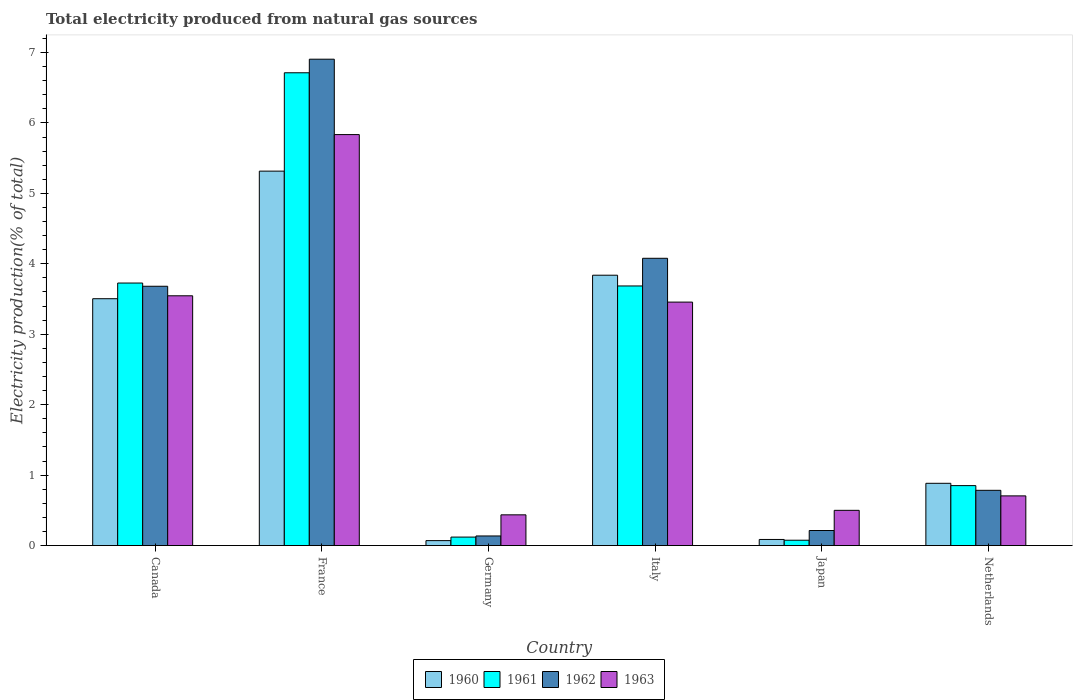How many different coloured bars are there?
Offer a terse response. 4. How many bars are there on the 5th tick from the right?
Your answer should be compact. 4. In how many cases, is the number of bars for a given country not equal to the number of legend labels?
Your answer should be very brief. 0. What is the total electricity produced in 1960 in Italy?
Offer a terse response. 3.84. Across all countries, what is the maximum total electricity produced in 1961?
Provide a succinct answer. 6.71. Across all countries, what is the minimum total electricity produced in 1962?
Your answer should be very brief. 0.14. In which country was the total electricity produced in 1961 minimum?
Make the answer very short. Japan. What is the total total electricity produced in 1960 in the graph?
Keep it short and to the point. 13.7. What is the difference between the total electricity produced in 1960 in France and that in Japan?
Keep it short and to the point. 5.23. What is the difference between the total electricity produced in 1960 in Germany and the total electricity produced in 1961 in Japan?
Your response must be concise. -0.01. What is the average total electricity produced in 1963 per country?
Provide a succinct answer. 2.41. What is the difference between the total electricity produced of/in 1963 and total electricity produced of/in 1960 in Germany?
Your answer should be compact. 0.37. What is the ratio of the total electricity produced in 1960 in Canada to that in Japan?
Your answer should be very brief. 40.48. Is the total electricity produced in 1961 in Germany less than that in Japan?
Offer a very short reply. No. Is the difference between the total electricity produced in 1963 in Italy and Netherlands greater than the difference between the total electricity produced in 1960 in Italy and Netherlands?
Keep it short and to the point. No. What is the difference between the highest and the second highest total electricity produced in 1963?
Offer a terse response. -0.09. What is the difference between the highest and the lowest total electricity produced in 1961?
Provide a succinct answer. 6.64. In how many countries, is the total electricity produced in 1962 greater than the average total electricity produced in 1962 taken over all countries?
Ensure brevity in your answer.  3. Is the sum of the total electricity produced in 1960 in France and Italy greater than the maximum total electricity produced in 1963 across all countries?
Provide a succinct answer. Yes. How many countries are there in the graph?
Provide a short and direct response. 6. What is the difference between two consecutive major ticks on the Y-axis?
Keep it short and to the point. 1. Does the graph contain any zero values?
Offer a very short reply. No. Does the graph contain grids?
Your answer should be very brief. No. Where does the legend appear in the graph?
Provide a short and direct response. Bottom center. How many legend labels are there?
Ensure brevity in your answer.  4. What is the title of the graph?
Provide a succinct answer. Total electricity produced from natural gas sources. Does "2014" appear as one of the legend labels in the graph?
Offer a very short reply. No. What is the label or title of the Y-axis?
Keep it short and to the point. Electricity production(% of total). What is the Electricity production(% of total) in 1960 in Canada?
Make the answer very short. 3.5. What is the Electricity production(% of total) in 1961 in Canada?
Ensure brevity in your answer.  3.73. What is the Electricity production(% of total) in 1962 in Canada?
Your answer should be very brief. 3.68. What is the Electricity production(% of total) in 1963 in Canada?
Provide a succinct answer. 3.55. What is the Electricity production(% of total) in 1960 in France?
Your response must be concise. 5.32. What is the Electricity production(% of total) in 1961 in France?
Keep it short and to the point. 6.71. What is the Electricity production(% of total) of 1962 in France?
Keep it short and to the point. 6.91. What is the Electricity production(% of total) of 1963 in France?
Offer a very short reply. 5.83. What is the Electricity production(% of total) of 1960 in Germany?
Offer a terse response. 0.07. What is the Electricity production(% of total) of 1961 in Germany?
Offer a terse response. 0.12. What is the Electricity production(% of total) of 1962 in Germany?
Make the answer very short. 0.14. What is the Electricity production(% of total) in 1963 in Germany?
Your answer should be very brief. 0.44. What is the Electricity production(% of total) in 1960 in Italy?
Provide a succinct answer. 3.84. What is the Electricity production(% of total) of 1961 in Italy?
Your answer should be compact. 3.69. What is the Electricity production(% of total) in 1962 in Italy?
Give a very brief answer. 4.08. What is the Electricity production(% of total) in 1963 in Italy?
Provide a succinct answer. 3.46. What is the Electricity production(% of total) of 1960 in Japan?
Give a very brief answer. 0.09. What is the Electricity production(% of total) in 1961 in Japan?
Your answer should be very brief. 0.08. What is the Electricity production(% of total) of 1962 in Japan?
Keep it short and to the point. 0.21. What is the Electricity production(% of total) in 1963 in Japan?
Give a very brief answer. 0.5. What is the Electricity production(% of total) of 1960 in Netherlands?
Keep it short and to the point. 0.88. What is the Electricity production(% of total) in 1961 in Netherlands?
Your answer should be very brief. 0.85. What is the Electricity production(% of total) in 1962 in Netherlands?
Your answer should be very brief. 0.78. What is the Electricity production(% of total) of 1963 in Netherlands?
Your response must be concise. 0.71. Across all countries, what is the maximum Electricity production(% of total) in 1960?
Your answer should be compact. 5.32. Across all countries, what is the maximum Electricity production(% of total) in 1961?
Ensure brevity in your answer.  6.71. Across all countries, what is the maximum Electricity production(% of total) in 1962?
Make the answer very short. 6.91. Across all countries, what is the maximum Electricity production(% of total) of 1963?
Provide a succinct answer. 5.83. Across all countries, what is the minimum Electricity production(% of total) of 1960?
Make the answer very short. 0.07. Across all countries, what is the minimum Electricity production(% of total) of 1961?
Your answer should be compact. 0.08. Across all countries, what is the minimum Electricity production(% of total) in 1962?
Give a very brief answer. 0.14. Across all countries, what is the minimum Electricity production(% of total) of 1963?
Offer a very short reply. 0.44. What is the total Electricity production(% of total) of 1960 in the graph?
Your answer should be very brief. 13.7. What is the total Electricity production(% of total) of 1961 in the graph?
Ensure brevity in your answer.  15.17. What is the total Electricity production(% of total) of 1962 in the graph?
Give a very brief answer. 15.8. What is the total Electricity production(% of total) in 1963 in the graph?
Provide a short and direct response. 14.48. What is the difference between the Electricity production(% of total) of 1960 in Canada and that in France?
Ensure brevity in your answer.  -1.81. What is the difference between the Electricity production(% of total) in 1961 in Canada and that in France?
Provide a succinct answer. -2.99. What is the difference between the Electricity production(% of total) in 1962 in Canada and that in France?
Your answer should be very brief. -3.22. What is the difference between the Electricity production(% of total) of 1963 in Canada and that in France?
Keep it short and to the point. -2.29. What is the difference between the Electricity production(% of total) of 1960 in Canada and that in Germany?
Your answer should be very brief. 3.43. What is the difference between the Electricity production(% of total) in 1961 in Canada and that in Germany?
Your answer should be compact. 3.61. What is the difference between the Electricity production(% of total) of 1962 in Canada and that in Germany?
Your response must be concise. 3.55. What is the difference between the Electricity production(% of total) in 1963 in Canada and that in Germany?
Your response must be concise. 3.11. What is the difference between the Electricity production(% of total) of 1960 in Canada and that in Italy?
Provide a short and direct response. -0.33. What is the difference between the Electricity production(% of total) in 1961 in Canada and that in Italy?
Keep it short and to the point. 0.04. What is the difference between the Electricity production(% of total) of 1962 in Canada and that in Italy?
Provide a short and direct response. -0.4. What is the difference between the Electricity production(% of total) of 1963 in Canada and that in Italy?
Provide a short and direct response. 0.09. What is the difference between the Electricity production(% of total) of 1960 in Canada and that in Japan?
Provide a succinct answer. 3.42. What is the difference between the Electricity production(% of total) of 1961 in Canada and that in Japan?
Offer a terse response. 3.65. What is the difference between the Electricity production(% of total) in 1962 in Canada and that in Japan?
Ensure brevity in your answer.  3.47. What is the difference between the Electricity production(% of total) in 1963 in Canada and that in Japan?
Offer a terse response. 3.05. What is the difference between the Electricity production(% of total) in 1960 in Canada and that in Netherlands?
Provide a short and direct response. 2.62. What is the difference between the Electricity production(% of total) of 1961 in Canada and that in Netherlands?
Offer a very short reply. 2.88. What is the difference between the Electricity production(% of total) in 1962 in Canada and that in Netherlands?
Your answer should be compact. 2.9. What is the difference between the Electricity production(% of total) in 1963 in Canada and that in Netherlands?
Your answer should be compact. 2.84. What is the difference between the Electricity production(% of total) in 1960 in France and that in Germany?
Offer a terse response. 5.25. What is the difference between the Electricity production(% of total) of 1961 in France and that in Germany?
Ensure brevity in your answer.  6.59. What is the difference between the Electricity production(% of total) in 1962 in France and that in Germany?
Provide a succinct answer. 6.77. What is the difference between the Electricity production(% of total) in 1963 in France and that in Germany?
Offer a very short reply. 5.4. What is the difference between the Electricity production(% of total) in 1960 in France and that in Italy?
Ensure brevity in your answer.  1.48. What is the difference between the Electricity production(% of total) in 1961 in France and that in Italy?
Offer a very short reply. 3.03. What is the difference between the Electricity production(% of total) of 1962 in France and that in Italy?
Keep it short and to the point. 2.83. What is the difference between the Electricity production(% of total) of 1963 in France and that in Italy?
Provide a succinct answer. 2.38. What is the difference between the Electricity production(% of total) in 1960 in France and that in Japan?
Make the answer very short. 5.23. What is the difference between the Electricity production(% of total) of 1961 in France and that in Japan?
Provide a short and direct response. 6.64. What is the difference between the Electricity production(% of total) of 1962 in France and that in Japan?
Ensure brevity in your answer.  6.69. What is the difference between the Electricity production(% of total) of 1963 in France and that in Japan?
Give a very brief answer. 5.33. What is the difference between the Electricity production(% of total) of 1960 in France and that in Netherlands?
Offer a terse response. 4.43. What is the difference between the Electricity production(% of total) of 1961 in France and that in Netherlands?
Ensure brevity in your answer.  5.86. What is the difference between the Electricity production(% of total) in 1962 in France and that in Netherlands?
Offer a very short reply. 6.12. What is the difference between the Electricity production(% of total) in 1963 in France and that in Netherlands?
Your answer should be compact. 5.13. What is the difference between the Electricity production(% of total) of 1960 in Germany and that in Italy?
Your response must be concise. -3.77. What is the difference between the Electricity production(% of total) of 1961 in Germany and that in Italy?
Give a very brief answer. -3.57. What is the difference between the Electricity production(% of total) in 1962 in Germany and that in Italy?
Offer a terse response. -3.94. What is the difference between the Electricity production(% of total) in 1963 in Germany and that in Italy?
Offer a very short reply. -3.02. What is the difference between the Electricity production(% of total) in 1960 in Germany and that in Japan?
Provide a succinct answer. -0.02. What is the difference between the Electricity production(% of total) of 1961 in Germany and that in Japan?
Make the answer very short. 0.04. What is the difference between the Electricity production(% of total) of 1962 in Germany and that in Japan?
Give a very brief answer. -0.08. What is the difference between the Electricity production(% of total) of 1963 in Germany and that in Japan?
Offer a terse response. -0.06. What is the difference between the Electricity production(% of total) in 1960 in Germany and that in Netherlands?
Your response must be concise. -0.81. What is the difference between the Electricity production(% of total) in 1961 in Germany and that in Netherlands?
Keep it short and to the point. -0.73. What is the difference between the Electricity production(% of total) in 1962 in Germany and that in Netherlands?
Ensure brevity in your answer.  -0.65. What is the difference between the Electricity production(% of total) of 1963 in Germany and that in Netherlands?
Provide a succinct answer. -0.27. What is the difference between the Electricity production(% of total) in 1960 in Italy and that in Japan?
Ensure brevity in your answer.  3.75. What is the difference between the Electricity production(% of total) of 1961 in Italy and that in Japan?
Your answer should be compact. 3.61. What is the difference between the Electricity production(% of total) of 1962 in Italy and that in Japan?
Provide a short and direct response. 3.86. What is the difference between the Electricity production(% of total) in 1963 in Italy and that in Japan?
Your response must be concise. 2.96. What is the difference between the Electricity production(% of total) in 1960 in Italy and that in Netherlands?
Keep it short and to the point. 2.95. What is the difference between the Electricity production(% of total) of 1961 in Italy and that in Netherlands?
Your answer should be very brief. 2.83. What is the difference between the Electricity production(% of total) in 1962 in Italy and that in Netherlands?
Your answer should be compact. 3.29. What is the difference between the Electricity production(% of total) of 1963 in Italy and that in Netherlands?
Offer a terse response. 2.75. What is the difference between the Electricity production(% of total) of 1960 in Japan and that in Netherlands?
Your answer should be very brief. -0.8. What is the difference between the Electricity production(% of total) in 1961 in Japan and that in Netherlands?
Offer a terse response. -0.78. What is the difference between the Electricity production(% of total) in 1962 in Japan and that in Netherlands?
Your answer should be very brief. -0.57. What is the difference between the Electricity production(% of total) in 1963 in Japan and that in Netherlands?
Give a very brief answer. -0.21. What is the difference between the Electricity production(% of total) of 1960 in Canada and the Electricity production(% of total) of 1961 in France?
Your answer should be compact. -3.21. What is the difference between the Electricity production(% of total) in 1960 in Canada and the Electricity production(% of total) in 1962 in France?
Make the answer very short. -3.4. What is the difference between the Electricity production(% of total) of 1960 in Canada and the Electricity production(% of total) of 1963 in France?
Your answer should be compact. -2.33. What is the difference between the Electricity production(% of total) of 1961 in Canada and the Electricity production(% of total) of 1962 in France?
Keep it short and to the point. -3.18. What is the difference between the Electricity production(% of total) in 1961 in Canada and the Electricity production(% of total) in 1963 in France?
Your answer should be compact. -2.11. What is the difference between the Electricity production(% of total) of 1962 in Canada and the Electricity production(% of total) of 1963 in France?
Your answer should be very brief. -2.15. What is the difference between the Electricity production(% of total) of 1960 in Canada and the Electricity production(% of total) of 1961 in Germany?
Make the answer very short. 3.38. What is the difference between the Electricity production(% of total) in 1960 in Canada and the Electricity production(% of total) in 1962 in Germany?
Your answer should be compact. 3.37. What is the difference between the Electricity production(% of total) in 1960 in Canada and the Electricity production(% of total) in 1963 in Germany?
Make the answer very short. 3.07. What is the difference between the Electricity production(% of total) of 1961 in Canada and the Electricity production(% of total) of 1962 in Germany?
Ensure brevity in your answer.  3.59. What is the difference between the Electricity production(% of total) in 1961 in Canada and the Electricity production(% of total) in 1963 in Germany?
Your response must be concise. 3.29. What is the difference between the Electricity production(% of total) in 1962 in Canada and the Electricity production(% of total) in 1963 in Germany?
Your answer should be very brief. 3.25. What is the difference between the Electricity production(% of total) in 1960 in Canada and the Electricity production(% of total) in 1961 in Italy?
Your answer should be compact. -0.18. What is the difference between the Electricity production(% of total) in 1960 in Canada and the Electricity production(% of total) in 1962 in Italy?
Your answer should be very brief. -0.57. What is the difference between the Electricity production(% of total) of 1960 in Canada and the Electricity production(% of total) of 1963 in Italy?
Provide a short and direct response. 0.05. What is the difference between the Electricity production(% of total) of 1961 in Canada and the Electricity production(% of total) of 1962 in Italy?
Your response must be concise. -0.35. What is the difference between the Electricity production(% of total) in 1961 in Canada and the Electricity production(% of total) in 1963 in Italy?
Your answer should be very brief. 0.27. What is the difference between the Electricity production(% of total) of 1962 in Canada and the Electricity production(% of total) of 1963 in Italy?
Give a very brief answer. 0.23. What is the difference between the Electricity production(% of total) of 1960 in Canada and the Electricity production(% of total) of 1961 in Japan?
Your response must be concise. 3.43. What is the difference between the Electricity production(% of total) of 1960 in Canada and the Electricity production(% of total) of 1962 in Japan?
Keep it short and to the point. 3.29. What is the difference between the Electricity production(% of total) in 1960 in Canada and the Electricity production(% of total) in 1963 in Japan?
Your response must be concise. 3. What is the difference between the Electricity production(% of total) of 1961 in Canada and the Electricity production(% of total) of 1962 in Japan?
Your answer should be very brief. 3.51. What is the difference between the Electricity production(% of total) in 1961 in Canada and the Electricity production(% of total) in 1963 in Japan?
Provide a short and direct response. 3.23. What is the difference between the Electricity production(% of total) of 1962 in Canada and the Electricity production(% of total) of 1963 in Japan?
Give a very brief answer. 3.18. What is the difference between the Electricity production(% of total) of 1960 in Canada and the Electricity production(% of total) of 1961 in Netherlands?
Keep it short and to the point. 2.65. What is the difference between the Electricity production(% of total) of 1960 in Canada and the Electricity production(% of total) of 1962 in Netherlands?
Give a very brief answer. 2.72. What is the difference between the Electricity production(% of total) of 1960 in Canada and the Electricity production(% of total) of 1963 in Netherlands?
Offer a terse response. 2.8. What is the difference between the Electricity production(% of total) in 1961 in Canada and the Electricity production(% of total) in 1962 in Netherlands?
Your response must be concise. 2.94. What is the difference between the Electricity production(% of total) in 1961 in Canada and the Electricity production(% of total) in 1963 in Netherlands?
Offer a terse response. 3.02. What is the difference between the Electricity production(% of total) in 1962 in Canada and the Electricity production(% of total) in 1963 in Netherlands?
Make the answer very short. 2.98. What is the difference between the Electricity production(% of total) of 1960 in France and the Electricity production(% of total) of 1961 in Germany?
Your response must be concise. 5.2. What is the difference between the Electricity production(% of total) of 1960 in France and the Electricity production(% of total) of 1962 in Germany?
Your answer should be very brief. 5.18. What is the difference between the Electricity production(% of total) of 1960 in France and the Electricity production(% of total) of 1963 in Germany?
Make the answer very short. 4.88. What is the difference between the Electricity production(% of total) in 1961 in France and the Electricity production(% of total) in 1962 in Germany?
Make the answer very short. 6.58. What is the difference between the Electricity production(% of total) in 1961 in France and the Electricity production(% of total) in 1963 in Germany?
Provide a succinct answer. 6.28. What is the difference between the Electricity production(% of total) in 1962 in France and the Electricity production(% of total) in 1963 in Germany?
Offer a very short reply. 6.47. What is the difference between the Electricity production(% of total) in 1960 in France and the Electricity production(% of total) in 1961 in Italy?
Give a very brief answer. 1.63. What is the difference between the Electricity production(% of total) in 1960 in France and the Electricity production(% of total) in 1962 in Italy?
Give a very brief answer. 1.24. What is the difference between the Electricity production(% of total) in 1960 in France and the Electricity production(% of total) in 1963 in Italy?
Give a very brief answer. 1.86. What is the difference between the Electricity production(% of total) of 1961 in France and the Electricity production(% of total) of 1962 in Italy?
Ensure brevity in your answer.  2.63. What is the difference between the Electricity production(% of total) of 1961 in France and the Electricity production(% of total) of 1963 in Italy?
Give a very brief answer. 3.26. What is the difference between the Electricity production(% of total) of 1962 in France and the Electricity production(% of total) of 1963 in Italy?
Keep it short and to the point. 3.45. What is the difference between the Electricity production(% of total) in 1960 in France and the Electricity production(% of total) in 1961 in Japan?
Offer a terse response. 5.24. What is the difference between the Electricity production(% of total) in 1960 in France and the Electricity production(% of total) in 1962 in Japan?
Keep it short and to the point. 5.1. What is the difference between the Electricity production(% of total) of 1960 in France and the Electricity production(% of total) of 1963 in Japan?
Offer a very short reply. 4.82. What is the difference between the Electricity production(% of total) in 1961 in France and the Electricity production(% of total) in 1962 in Japan?
Make the answer very short. 6.5. What is the difference between the Electricity production(% of total) of 1961 in France and the Electricity production(% of total) of 1963 in Japan?
Your answer should be compact. 6.21. What is the difference between the Electricity production(% of total) in 1962 in France and the Electricity production(% of total) in 1963 in Japan?
Ensure brevity in your answer.  6.4. What is the difference between the Electricity production(% of total) in 1960 in France and the Electricity production(% of total) in 1961 in Netherlands?
Offer a very short reply. 4.46. What is the difference between the Electricity production(% of total) of 1960 in France and the Electricity production(% of total) of 1962 in Netherlands?
Your response must be concise. 4.53. What is the difference between the Electricity production(% of total) in 1960 in France and the Electricity production(% of total) in 1963 in Netherlands?
Your response must be concise. 4.61. What is the difference between the Electricity production(% of total) of 1961 in France and the Electricity production(% of total) of 1962 in Netherlands?
Your answer should be compact. 5.93. What is the difference between the Electricity production(% of total) in 1961 in France and the Electricity production(% of total) in 1963 in Netherlands?
Ensure brevity in your answer.  6.01. What is the difference between the Electricity production(% of total) of 1962 in France and the Electricity production(% of total) of 1963 in Netherlands?
Your response must be concise. 6.2. What is the difference between the Electricity production(% of total) in 1960 in Germany and the Electricity production(% of total) in 1961 in Italy?
Offer a terse response. -3.62. What is the difference between the Electricity production(% of total) in 1960 in Germany and the Electricity production(% of total) in 1962 in Italy?
Your answer should be compact. -4.01. What is the difference between the Electricity production(% of total) in 1960 in Germany and the Electricity production(% of total) in 1963 in Italy?
Provide a short and direct response. -3.39. What is the difference between the Electricity production(% of total) of 1961 in Germany and the Electricity production(% of total) of 1962 in Italy?
Give a very brief answer. -3.96. What is the difference between the Electricity production(% of total) in 1961 in Germany and the Electricity production(% of total) in 1963 in Italy?
Keep it short and to the point. -3.34. What is the difference between the Electricity production(% of total) in 1962 in Germany and the Electricity production(% of total) in 1963 in Italy?
Make the answer very short. -3.32. What is the difference between the Electricity production(% of total) in 1960 in Germany and the Electricity production(% of total) in 1961 in Japan?
Your response must be concise. -0.01. What is the difference between the Electricity production(% of total) in 1960 in Germany and the Electricity production(% of total) in 1962 in Japan?
Provide a short and direct response. -0.14. What is the difference between the Electricity production(% of total) of 1960 in Germany and the Electricity production(% of total) of 1963 in Japan?
Your answer should be compact. -0.43. What is the difference between the Electricity production(% of total) of 1961 in Germany and the Electricity production(% of total) of 1962 in Japan?
Make the answer very short. -0.09. What is the difference between the Electricity production(% of total) of 1961 in Germany and the Electricity production(% of total) of 1963 in Japan?
Keep it short and to the point. -0.38. What is the difference between the Electricity production(% of total) of 1962 in Germany and the Electricity production(% of total) of 1963 in Japan?
Provide a short and direct response. -0.36. What is the difference between the Electricity production(% of total) of 1960 in Germany and the Electricity production(% of total) of 1961 in Netherlands?
Your answer should be compact. -0.78. What is the difference between the Electricity production(% of total) in 1960 in Germany and the Electricity production(% of total) in 1962 in Netherlands?
Ensure brevity in your answer.  -0.71. What is the difference between the Electricity production(% of total) in 1960 in Germany and the Electricity production(% of total) in 1963 in Netherlands?
Your answer should be compact. -0.64. What is the difference between the Electricity production(% of total) in 1961 in Germany and the Electricity production(% of total) in 1962 in Netherlands?
Your answer should be very brief. -0.66. What is the difference between the Electricity production(% of total) in 1961 in Germany and the Electricity production(% of total) in 1963 in Netherlands?
Your answer should be very brief. -0.58. What is the difference between the Electricity production(% of total) of 1962 in Germany and the Electricity production(% of total) of 1963 in Netherlands?
Keep it short and to the point. -0.57. What is the difference between the Electricity production(% of total) of 1960 in Italy and the Electricity production(% of total) of 1961 in Japan?
Keep it short and to the point. 3.76. What is the difference between the Electricity production(% of total) in 1960 in Italy and the Electricity production(% of total) in 1962 in Japan?
Your answer should be very brief. 3.62. What is the difference between the Electricity production(% of total) of 1960 in Italy and the Electricity production(% of total) of 1963 in Japan?
Provide a short and direct response. 3.34. What is the difference between the Electricity production(% of total) in 1961 in Italy and the Electricity production(% of total) in 1962 in Japan?
Offer a very short reply. 3.47. What is the difference between the Electricity production(% of total) in 1961 in Italy and the Electricity production(% of total) in 1963 in Japan?
Provide a short and direct response. 3.19. What is the difference between the Electricity production(% of total) of 1962 in Italy and the Electricity production(% of total) of 1963 in Japan?
Provide a short and direct response. 3.58. What is the difference between the Electricity production(% of total) of 1960 in Italy and the Electricity production(% of total) of 1961 in Netherlands?
Keep it short and to the point. 2.99. What is the difference between the Electricity production(% of total) of 1960 in Italy and the Electricity production(% of total) of 1962 in Netherlands?
Provide a succinct answer. 3.05. What is the difference between the Electricity production(% of total) of 1960 in Italy and the Electricity production(% of total) of 1963 in Netherlands?
Your answer should be very brief. 3.13. What is the difference between the Electricity production(% of total) in 1961 in Italy and the Electricity production(% of total) in 1962 in Netherlands?
Give a very brief answer. 2.9. What is the difference between the Electricity production(% of total) in 1961 in Italy and the Electricity production(% of total) in 1963 in Netherlands?
Offer a very short reply. 2.98. What is the difference between the Electricity production(% of total) in 1962 in Italy and the Electricity production(% of total) in 1963 in Netherlands?
Make the answer very short. 3.37. What is the difference between the Electricity production(% of total) of 1960 in Japan and the Electricity production(% of total) of 1961 in Netherlands?
Provide a succinct answer. -0.76. What is the difference between the Electricity production(% of total) of 1960 in Japan and the Electricity production(% of total) of 1962 in Netherlands?
Give a very brief answer. -0.7. What is the difference between the Electricity production(% of total) in 1960 in Japan and the Electricity production(% of total) in 1963 in Netherlands?
Keep it short and to the point. -0.62. What is the difference between the Electricity production(% of total) of 1961 in Japan and the Electricity production(% of total) of 1962 in Netherlands?
Offer a terse response. -0.71. What is the difference between the Electricity production(% of total) in 1961 in Japan and the Electricity production(% of total) in 1963 in Netherlands?
Provide a succinct answer. -0.63. What is the difference between the Electricity production(% of total) of 1962 in Japan and the Electricity production(% of total) of 1963 in Netherlands?
Offer a very short reply. -0.49. What is the average Electricity production(% of total) of 1960 per country?
Offer a very short reply. 2.28. What is the average Electricity production(% of total) in 1961 per country?
Your answer should be very brief. 2.53. What is the average Electricity production(% of total) in 1962 per country?
Offer a terse response. 2.63. What is the average Electricity production(% of total) in 1963 per country?
Your answer should be compact. 2.41. What is the difference between the Electricity production(% of total) of 1960 and Electricity production(% of total) of 1961 in Canada?
Make the answer very short. -0.22. What is the difference between the Electricity production(% of total) in 1960 and Electricity production(% of total) in 1962 in Canada?
Your response must be concise. -0.18. What is the difference between the Electricity production(% of total) in 1960 and Electricity production(% of total) in 1963 in Canada?
Give a very brief answer. -0.04. What is the difference between the Electricity production(% of total) in 1961 and Electricity production(% of total) in 1962 in Canada?
Keep it short and to the point. 0.05. What is the difference between the Electricity production(% of total) of 1961 and Electricity production(% of total) of 1963 in Canada?
Offer a very short reply. 0.18. What is the difference between the Electricity production(% of total) in 1962 and Electricity production(% of total) in 1963 in Canada?
Keep it short and to the point. 0.14. What is the difference between the Electricity production(% of total) in 1960 and Electricity production(% of total) in 1961 in France?
Make the answer very short. -1.4. What is the difference between the Electricity production(% of total) of 1960 and Electricity production(% of total) of 1962 in France?
Offer a terse response. -1.59. What is the difference between the Electricity production(% of total) of 1960 and Electricity production(% of total) of 1963 in France?
Make the answer very short. -0.52. What is the difference between the Electricity production(% of total) in 1961 and Electricity production(% of total) in 1962 in France?
Your answer should be compact. -0.19. What is the difference between the Electricity production(% of total) in 1961 and Electricity production(% of total) in 1963 in France?
Provide a short and direct response. 0.88. What is the difference between the Electricity production(% of total) in 1962 and Electricity production(% of total) in 1963 in France?
Ensure brevity in your answer.  1.07. What is the difference between the Electricity production(% of total) of 1960 and Electricity production(% of total) of 1961 in Germany?
Give a very brief answer. -0.05. What is the difference between the Electricity production(% of total) in 1960 and Electricity production(% of total) in 1962 in Germany?
Offer a very short reply. -0.07. What is the difference between the Electricity production(% of total) in 1960 and Electricity production(% of total) in 1963 in Germany?
Keep it short and to the point. -0.37. What is the difference between the Electricity production(% of total) of 1961 and Electricity production(% of total) of 1962 in Germany?
Provide a short and direct response. -0.02. What is the difference between the Electricity production(% of total) in 1961 and Electricity production(% of total) in 1963 in Germany?
Give a very brief answer. -0.32. What is the difference between the Electricity production(% of total) of 1962 and Electricity production(% of total) of 1963 in Germany?
Offer a very short reply. -0.3. What is the difference between the Electricity production(% of total) in 1960 and Electricity production(% of total) in 1961 in Italy?
Your answer should be very brief. 0.15. What is the difference between the Electricity production(% of total) in 1960 and Electricity production(% of total) in 1962 in Italy?
Ensure brevity in your answer.  -0.24. What is the difference between the Electricity production(% of total) in 1960 and Electricity production(% of total) in 1963 in Italy?
Ensure brevity in your answer.  0.38. What is the difference between the Electricity production(% of total) of 1961 and Electricity production(% of total) of 1962 in Italy?
Your answer should be compact. -0.39. What is the difference between the Electricity production(% of total) of 1961 and Electricity production(% of total) of 1963 in Italy?
Your response must be concise. 0.23. What is the difference between the Electricity production(% of total) of 1962 and Electricity production(% of total) of 1963 in Italy?
Provide a succinct answer. 0.62. What is the difference between the Electricity production(% of total) in 1960 and Electricity production(% of total) in 1961 in Japan?
Offer a very short reply. 0.01. What is the difference between the Electricity production(% of total) of 1960 and Electricity production(% of total) of 1962 in Japan?
Provide a succinct answer. -0.13. What is the difference between the Electricity production(% of total) in 1960 and Electricity production(% of total) in 1963 in Japan?
Make the answer very short. -0.41. What is the difference between the Electricity production(% of total) of 1961 and Electricity production(% of total) of 1962 in Japan?
Your response must be concise. -0.14. What is the difference between the Electricity production(% of total) of 1961 and Electricity production(% of total) of 1963 in Japan?
Provide a succinct answer. -0.42. What is the difference between the Electricity production(% of total) of 1962 and Electricity production(% of total) of 1963 in Japan?
Make the answer very short. -0.29. What is the difference between the Electricity production(% of total) in 1960 and Electricity production(% of total) in 1961 in Netherlands?
Offer a terse response. 0.03. What is the difference between the Electricity production(% of total) in 1960 and Electricity production(% of total) in 1962 in Netherlands?
Your response must be concise. 0.1. What is the difference between the Electricity production(% of total) of 1960 and Electricity production(% of total) of 1963 in Netherlands?
Make the answer very short. 0.18. What is the difference between the Electricity production(% of total) in 1961 and Electricity production(% of total) in 1962 in Netherlands?
Your response must be concise. 0.07. What is the difference between the Electricity production(% of total) of 1961 and Electricity production(% of total) of 1963 in Netherlands?
Keep it short and to the point. 0.15. What is the difference between the Electricity production(% of total) of 1962 and Electricity production(% of total) of 1963 in Netherlands?
Offer a terse response. 0.08. What is the ratio of the Electricity production(% of total) of 1960 in Canada to that in France?
Your answer should be compact. 0.66. What is the ratio of the Electricity production(% of total) of 1961 in Canada to that in France?
Your answer should be compact. 0.56. What is the ratio of the Electricity production(% of total) of 1962 in Canada to that in France?
Give a very brief answer. 0.53. What is the ratio of the Electricity production(% of total) of 1963 in Canada to that in France?
Keep it short and to the point. 0.61. What is the ratio of the Electricity production(% of total) of 1960 in Canada to that in Germany?
Your answer should be very brief. 49.85. What is the ratio of the Electricity production(% of total) of 1961 in Canada to that in Germany?
Ensure brevity in your answer.  30.98. What is the ratio of the Electricity production(% of total) in 1962 in Canada to that in Germany?
Give a very brief answer. 27.02. What is the ratio of the Electricity production(% of total) in 1963 in Canada to that in Germany?
Make the answer very short. 8.13. What is the ratio of the Electricity production(% of total) of 1960 in Canada to that in Italy?
Your answer should be compact. 0.91. What is the ratio of the Electricity production(% of total) of 1961 in Canada to that in Italy?
Make the answer very short. 1.01. What is the ratio of the Electricity production(% of total) in 1962 in Canada to that in Italy?
Make the answer very short. 0.9. What is the ratio of the Electricity production(% of total) of 1963 in Canada to that in Italy?
Ensure brevity in your answer.  1.03. What is the ratio of the Electricity production(% of total) of 1960 in Canada to that in Japan?
Your answer should be compact. 40.48. What is the ratio of the Electricity production(% of total) of 1961 in Canada to that in Japan?
Offer a very short reply. 49.23. What is the ratio of the Electricity production(% of total) in 1962 in Canada to that in Japan?
Make the answer very short. 17.23. What is the ratio of the Electricity production(% of total) in 1963 in Canada to that in Japan?
Your answer should be compact. 7.09. What is the ratio of the Electricity production(% of total) of 1960 in Canada to that in Netherlands?
Provide a succinct answer. 3.96. What is the ratio of the Electricity production(% of total) of 1961 in Canada to that in Netherlands?
Offer a very short reply. 4.38. What is the ratio of the Electricity production(% of total) in 1962 in Canada to that in Netherlands?
Ensure brevity in your answer.  4.69. What is the ratio of the Electricity production(% of total) in 1963 in Canada to that in Netherlands?
Make the answer very short. 5.03. What is the ratio of the Electricity production(% of total) of 1960 in France to that in Germany?
Make the answer very short. 75.62. What is the ratio of the Electricity production(% of total) of 1961 in France to that in Germany?
Give a very brief answer. 55.79. What is the ratio of the Electricity production(% of total) in 1962 in France to that in Germany?
Provide a short and direct response. 50.69. What is the ratio of the Electricity production(% of total) in 1963 in France to that in Germany?
Provide a succinct answer. 13.38. What is the ratio of the Electricity production(% of total) in 1960 in France to that in Italy?
Keep it short and to the point. 1.39. What is the ratio of the Electricity production(% of total) of 1961 in France to that in Italy?
Your response must be concise. 1.82. What is the ratio of the Electricity production(% of total) of 1962 in France to that in Italy?
Offer a terse response. 1.69. What is the ratio of the Electricity production(% of total) of 1963 in France to that in Italy?
Your answer should be very brief. 1.69. What is the ratio of the Electricity production(% of total) of 1960 in France to that in Japan?
Keep it short and to the point. 61.4. What is the ratio of the Electricity production(% of total) of 1961 in France to that in Japan?
Keep it short and to the point. 88.67. What is the ratio of the Electricity production(% of total) of 1962 in France to that in Japan?
Make the answer very short. 32.32. What is the ratio of the Electricity production(% of total) of 1963 in France to that in Japan?
Provide a succinct answer. 11.67. What is the ratio of the Electricity production(% of total) in 1960 in France to that in Netherlands?
Provide a succinct answer. 6.01. What is the ratio of the Electricity production(% of total) in 1961 in France to that in Netherlands?
Your answer should be compact. 7.89. What is the ratio of the Electricity production(% of total) in 1962 in France to that in Netherlands?
Your answer should be compact. 8.8. What is the ratio of the Electricity production(% of total) in 1963 in France to that in Netherlands?
Provide a succinct answer. 8.27. What is the ratio of the Electricity production(% of total) in 1960 in Germany to that in Italy?
Your answer should be very brief. 0.02. What is the ratio of the Electricity production(% of total) in 1961 in Germany to that in Italy?
Keep it short and to the point. 0.03. What is the ratio of the Electricity production(% of total) in 1962 in Germany to that in Italy?
Offer a very short reply. 0.03. What is the ratio of the Electricity production(% of total) of 1963 in Germany to that in Italy?
Keep it short and to the point. 0.13. What is the ratio of the Electricity production(% of total) of 1960 in Germany to that in Japan?
Ensure brevity in your answer.  0.81. What is the ratio of the Electricity production(% of total) in 1961 in Germany to that in Japan?
Your answer should be very brief. 1.59. What is the ratio of the Electricity production(% of total) of 1962 in Germany to that in Japan?
Offer a terse response. 0.64. What is the ratio of the Electricity production(% of total) in 1963 in Germany to that in Japan?
Offer a terse response. 0.87. What is the ratio of the Electricity production(% of total) in 1960 in Germany to that in Netherlands?
Your response must be concise. 0.08. What is the ratio of the Electricity production(% of total) of 1961 in Germany to that in Netherlands?
Make the answer very short. 0.14. What is the ratio of the Electricity production(% of total) of 1962 in Germany to that in Netherlands?
Ensure brevity in your answer.  0.17. What is the ratio of the Electricity production(% of total) in 1963 in Germany to that in Netherlands?
Give a very brief answer. 0.62. What is the ratio of the Electricity production(% of total) in 1960 in Italy to that in Japan?
Your response must be concise. 44.33. What is the ratio of the Electricity production(% of total) of 1961 in Italy to that in Japan?
Offer a very short reply. 48.69. What is the ratio of the Electricity production(% of total) of 1962 in Italy to that in Japan?
Your response must be concise. 19.09. What is the ratio of the Electricity production(% of total) of 1963 in Italy to that in Japan?
Your answer should be compact. 6.91. What is the ratio of the Electricity production(% of total) of 1960 in Italy to that in Netherlands?
Provide a short and direct response. 4.34. What is the ratio of the Electricity production(% of total) in 1961 in Italy to that in Netherlands?
Your answer should be very brief. 4.33. What is the ratio of the Electricity production(% of total) of 1962 in Italy to that in Netherlands?
Offer a very short reply. 5.2. What is the ratio of the Electricity production(% of total) in 1963 in Italy to that in Netherlands?
Your answer should be very brief. 4.9. What is the ratio of the Electricity production(% of total) of 1960 in Japan to that in Netherlands?
Provide a succinct answer. 0.1. What is the ratio of the Electricity production(% of total) of 1961 in Japan to that in Netherlands?
Provide a short and direct response. 0.09. What is the ratio of the Electricity production(% of total) of 1962 in Japan to that in Netherlands?
Ensure brevity in your answer.  0.27. What is the ratio of the Electricity production(% of total) of 1963 in Japan to that in Netherlands?
Your answer should be very brief. 0.71. What is the difference between the highest and the second highest Electricity production(% of total) of 1960?
Provide a succinct answer. 1.48. What is the difference between the highest and the second highest Electricity production(% of total) in 1961?
Your answer should be very brief. 2.99. What is the difference between the highest and the second highest Electricity production(% of total) in 1962?
Provide a succinct answer. 2.83. What is the difference between the highest and the second highest Electricity production(% of total) in 1963?
Offer a terse response. 2.29. What is the difference between the highest and the lowest Electricity production(% of total) of 1960?
Your answer should be very brief. 5.25. What is the difference between the highest and the lowest Electricity production(% of total) of 1961?
Your response must be concise. 6.64. What is the difference between the highest and the lowest Electricity production(% of total) in 1962?
Make the answer very short. 6.77. What is the difference between the highest and the lowest Electricity production(% of total) of 1963?
Ensure brevity in your answer.  5.4. 